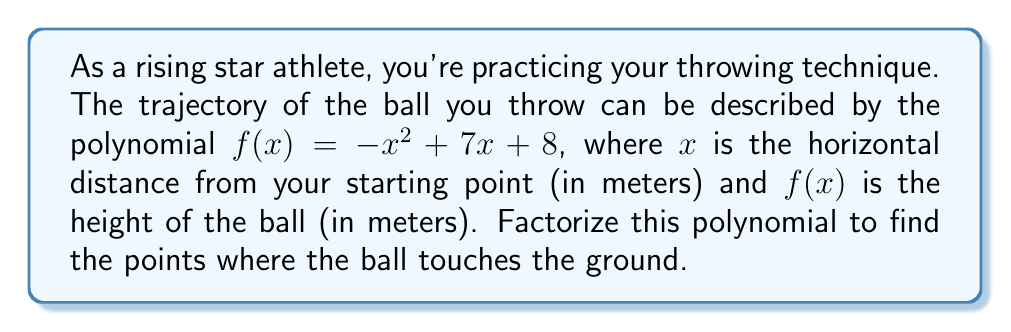What is the answer to this math problem? To factorize the polynomial $f(x) = -x^2 + 7x + 8$, we'll follow these steps:

1) First, we need to identify that this is a quadratic equation in the form $ax^2 + bx + c$, where:
   $a = -1$
   $b = 7$
   $c = 8$

2) To factorize, we'll use the quadratic formula: $x = \frac{-b \pm \sqrt{b^2 - 4ac}}{2a}$

3) Let's substitute our values:
   $x = \frac{-7 \pm \sqrt{7^2 - 4(-1)(8)}}{2(-1)}$

4) Simplify under the square root:
   $x = \frac{-7 \pm \sqrt{49 + 32}}{-2} = \frac{-7 \pm \sqrt{81}}{-2} = \frac{-7 \pm 9}{-2}$

5) This gives us two solutions:
   $x_1 = \frac{-7 + 9}{-2} = \frac{2}{-2} = -1$
   $x_2 = \frac{-7 - 9}{-2} = \frac{-16}{-2} = 8$

6) Therefore, the factored form of the polynomial is:
   $f(x) = -(x + 1)(x - 8)$

The roots of this polynomial (where $f(x) = 0$) represent the points where the ball touches the ground. These occur at $x = -1$ and $x = 8$.
Answer: $f(x) = -(x + 1)(x - 8)$ 